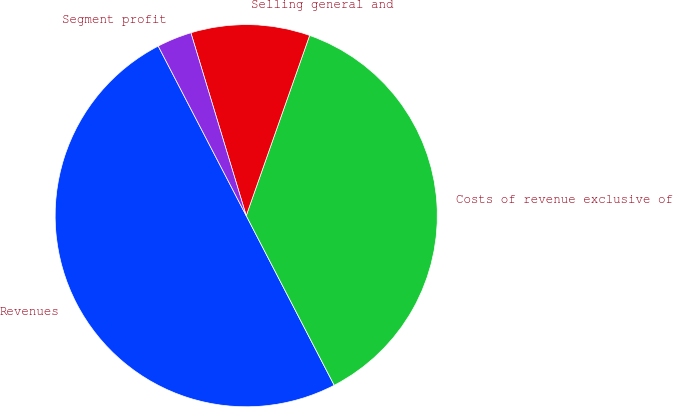Convert chart to OTSL. <chart><loc_0><loc_0><loc_500><loc_500><pie_chart><fcel>Revenues<fcel>Costs of revenue exclusive of<fcel>Selling general and<fcel>Segment profit<nl><fcel>50.0%<fcel>37.0%<fcel>10.06%<fcel>2.94%<nl></chart> 